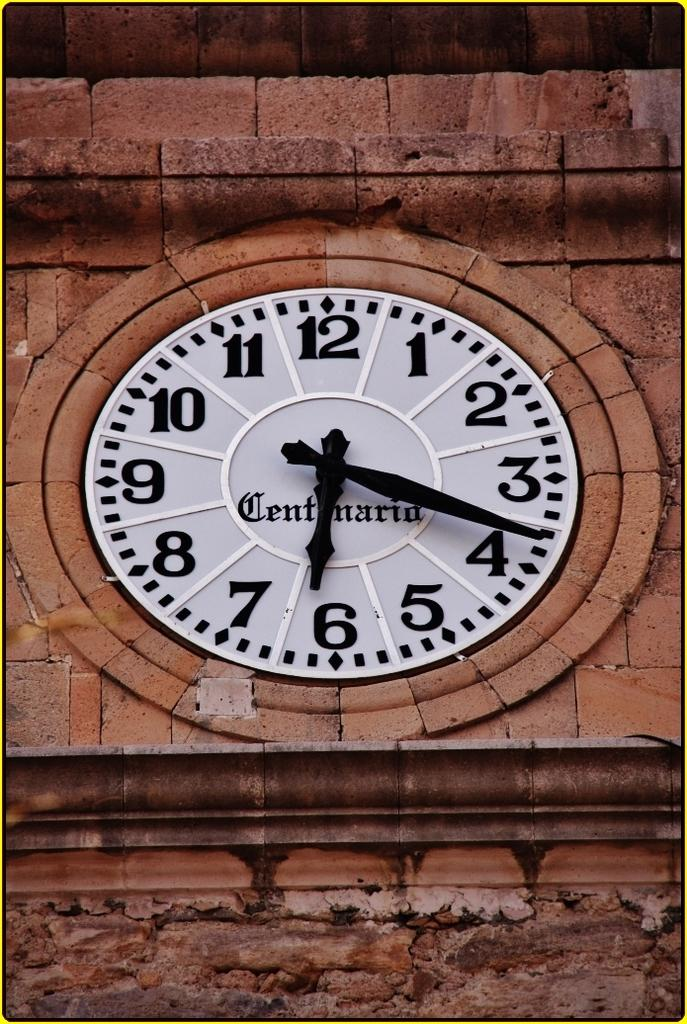<image>
Create a compact narrative representing the image presented. A large clock surrounded by stone reads 6:18 on its face. 